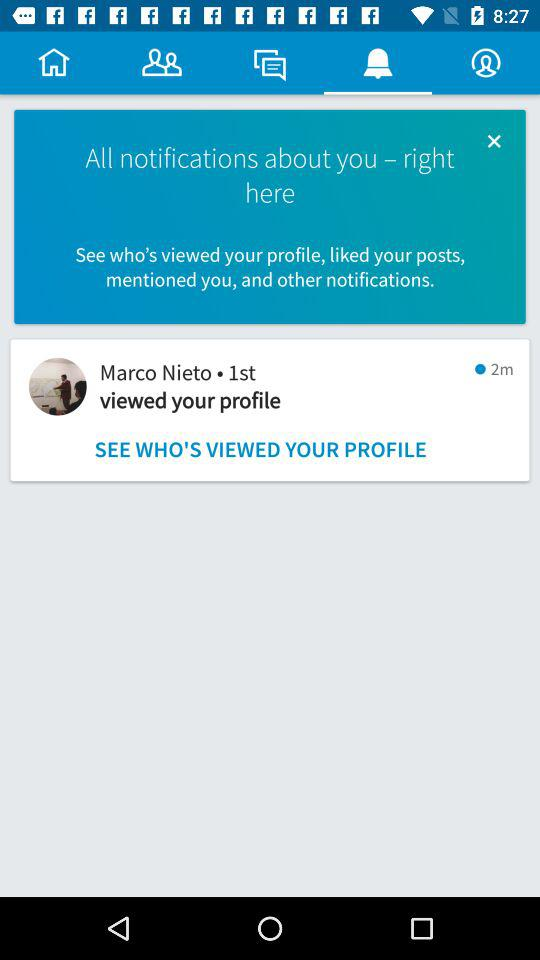How many minutes ago did Marco Nieto view your profile?
Answer the question using a single word or phrase. 2 